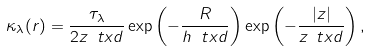Convert formula to latex. <formula><loc_0><loc_0><loc_500><loc_500>\kappa _ { \lambda } ( r ) = \frac { \tau _ { \lambda } } { 2 z _ { \ } t x d } \exp \left ( - \frac { R } { h _ { \ } t x d } \right ) \exp \left ( - \frac { | z | } { z _ { \ } t x d } \right ) ,</formula> 